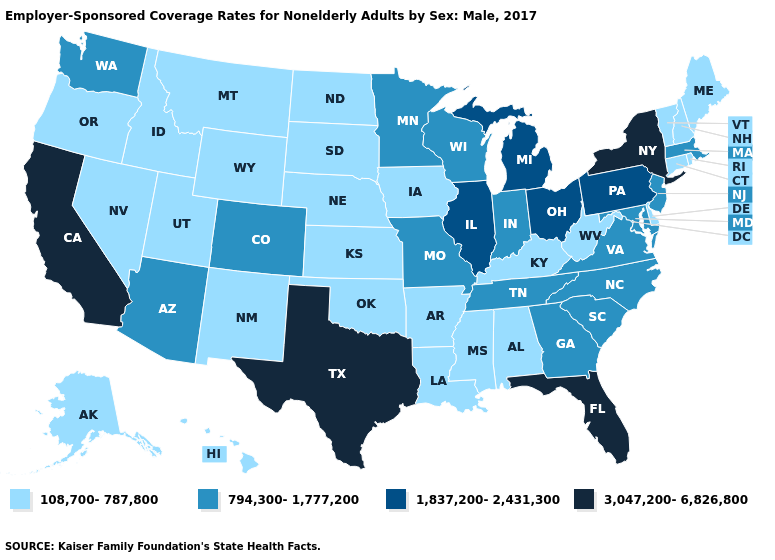Which states hav the highest value in the MidWest?
Be succinct. Illinois, Michigan, Ohio. Name the states that have a value in the range 3,047,200-6,826,800?
Quick response, please. California, Florida, New York, Texas. Is the legend a continuous bar?
Answer briefly. No. Does Massachusetts have the lowest value in the USA?
Give a very brief answer. No. Which states have the highest value in the USA?
Give a very brief answer. California, Florida, New York, Texas. What is the highest value in states that border Tennessee?
Concise answer only. 794,300-1,777,200. Which states have the lowest value in the USA?
Concise answer only. Alabama, Alaska, Arkansas, Connecticut, Delaware, Hawaii, Idaho, Iowa, Kansas, Kentucky, Louisiana, Maine, Mississippi, Montana, Nebraska, Nevada, New Hampshire, New Mexico, North Dakota, Oklahoma, Oregon, Rhode Island, South Dakota, Utah, Vermont, West Virginia, Wyoming. What is the highest value in states that border Michigan?
Answer briefly. 1,837,200-2,431,300. Does Pennsylvania have a lower value than Texas?
Write a very short answer. Yes. What is the value of West Virginia?
Concise answer only. 108,700-787,800. Which states have the highest value in the USA?
Quick response, please. California, Florida, New York, Texas. Does the first symbol in the legend represent the smallest category?
Be succinct. Yes. What is the highest value in the South ?
Short answer required. 3,047,200-6,826,800. Name the states that have a value in the range 108,700-787,800?
Keep it brief. Alabama, Alaska, Arkansas, Connecticut, Delaware, Hawaii, Idaho, Iowa, Kansas, Kentucky, Louisiana, Maine, Mississippi, Montana, Nebraska, Nevada, New Hampshire, New Mexico, North Dakota, Oklahoma, Oregon, Rhode Island, South Dakota, Utah, Vermont, West Virginia, Wyoming. 